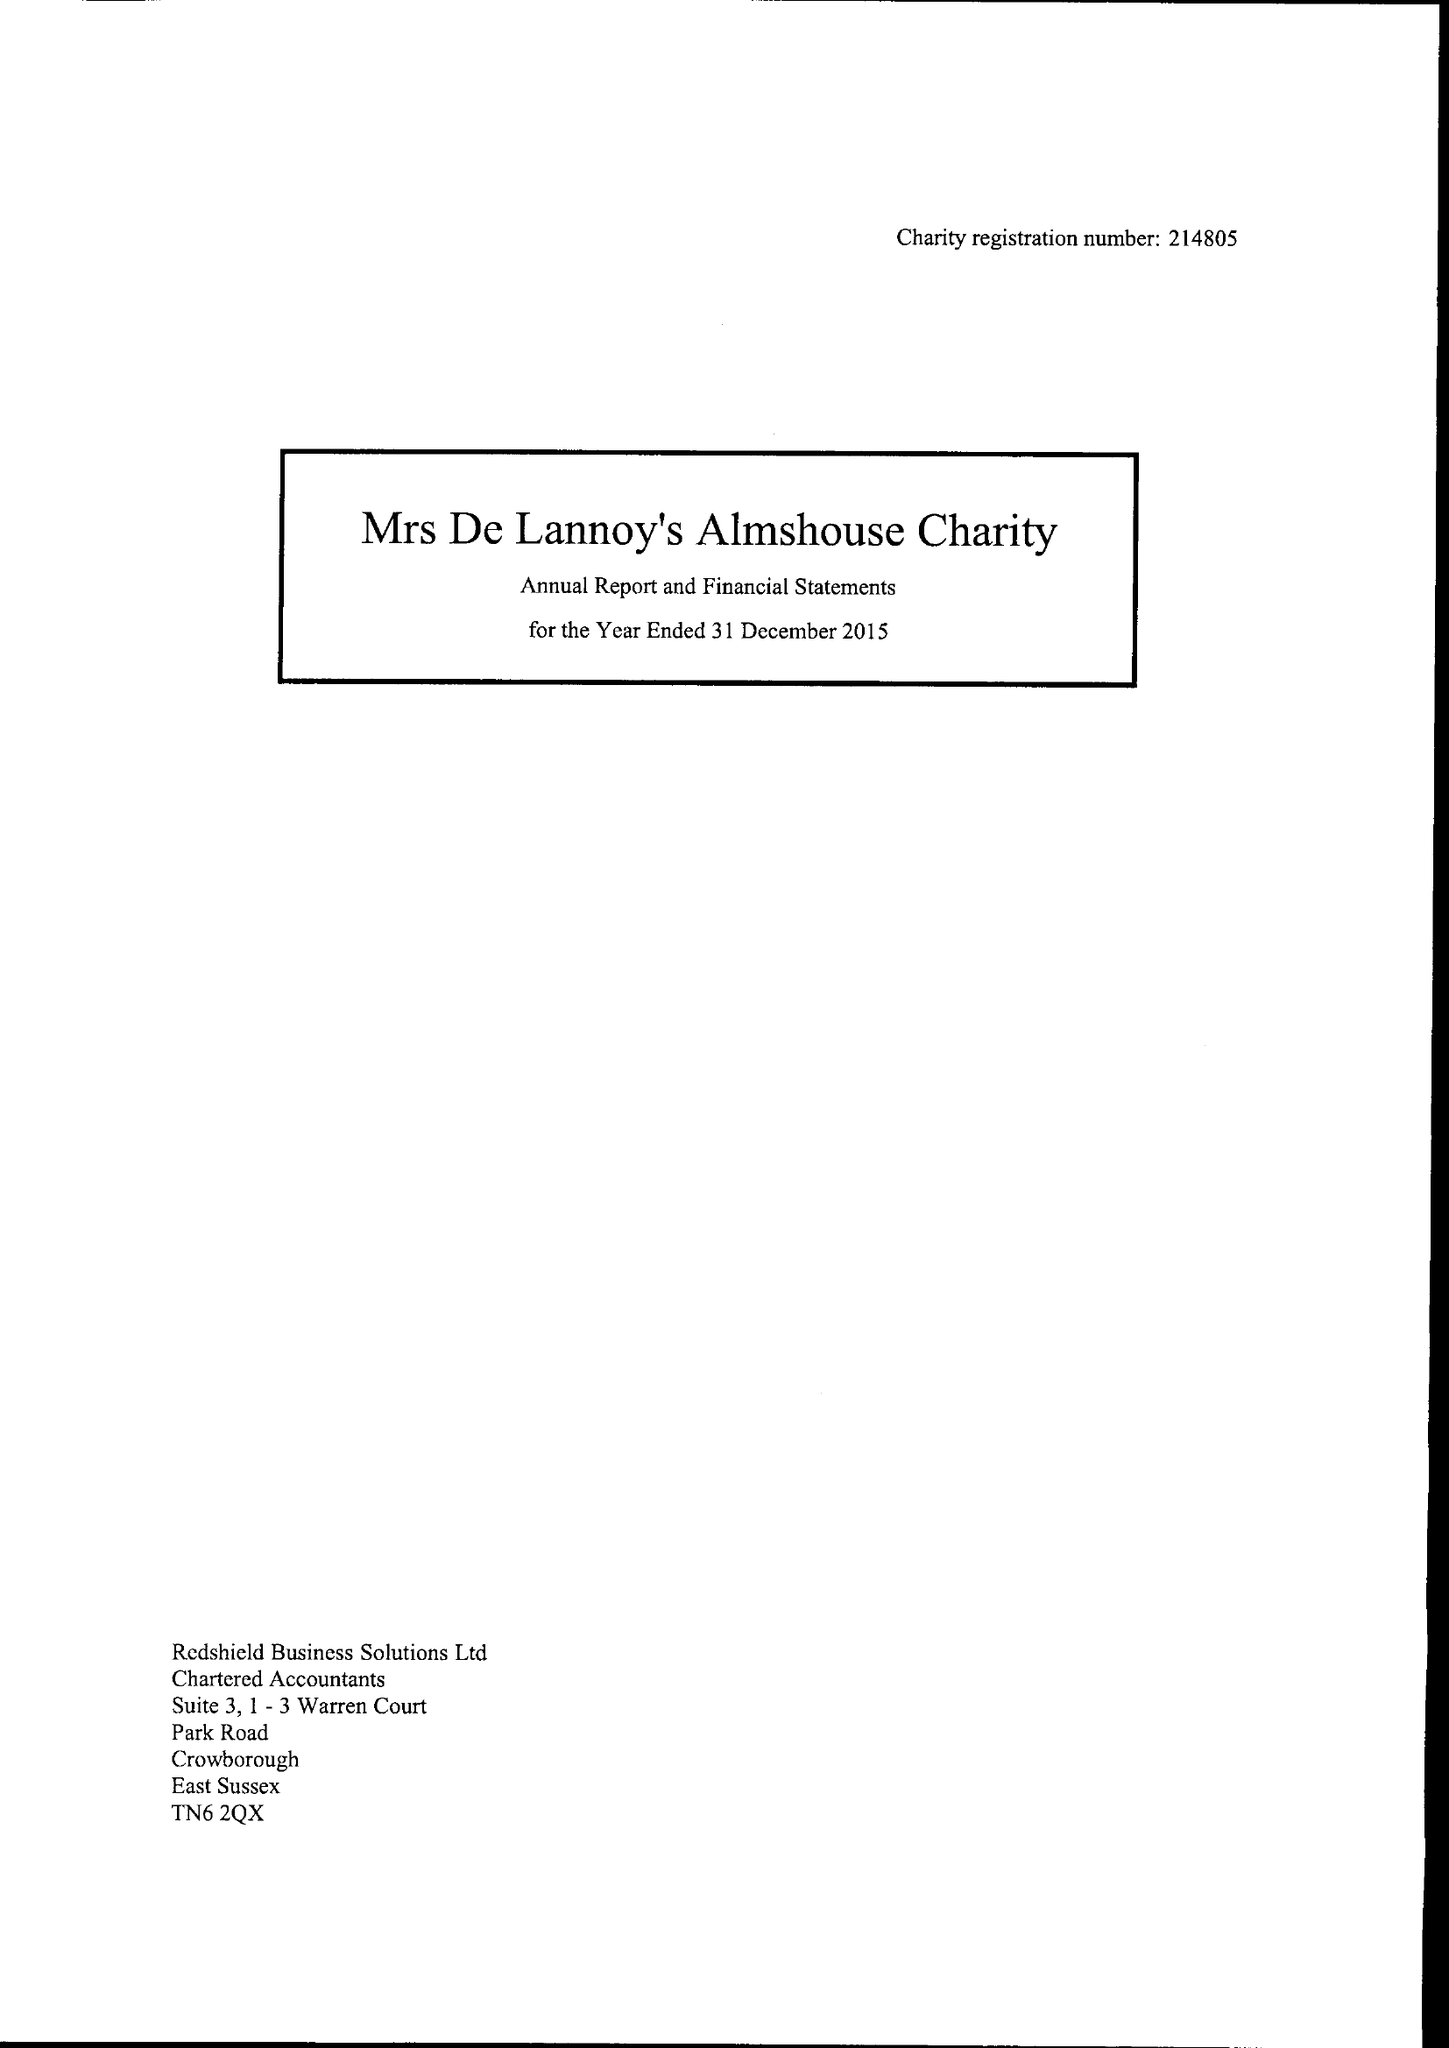What is the value for the charity_name?
Answer the question using a single word or phrase. Mrs De Lannoy and Haven Homes Almshouse Charity 